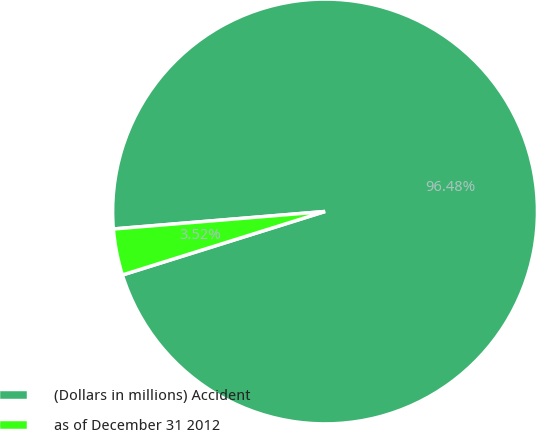<chart> <loc_0><loc_0><loc_500><loc_500><pie_chart><fcel>(Dollars in millions) Accident<fcel>as of December 31 2012<nl><fcel>96.48%<fcel>3.52%<nl></chart> 